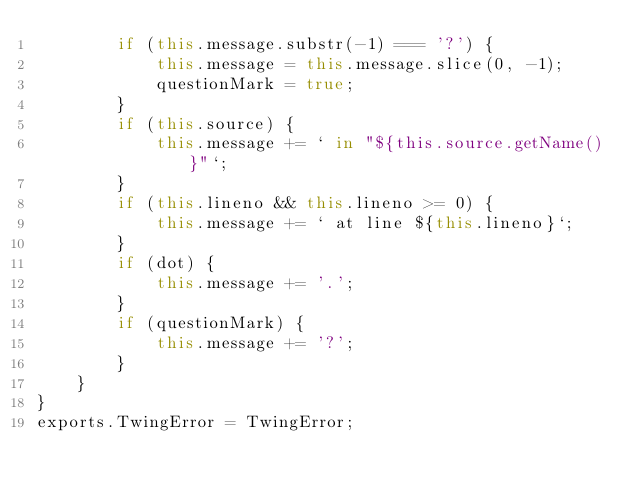<code> <loc_0><loc_0><loc_500><loc_500><_JavaScript_>        if (this.message.substr(-1) === '?') {
            this.message = this.message.slice(0, -1);
            questionMark = true;
        }
        if (this.source) {
            this.message += ` in "${this.source.getName()}"`;
        }
        if (this.lineno && this.lineno >= 0) {
            this.message += ` at line ${this.lineno}`;
        }
        if (dot) {
            this.message += '.';
        }
        if (questionMark) {
            this.message += '?';
        }
    }
}
exports.TwingError = TwingError;
</code> 